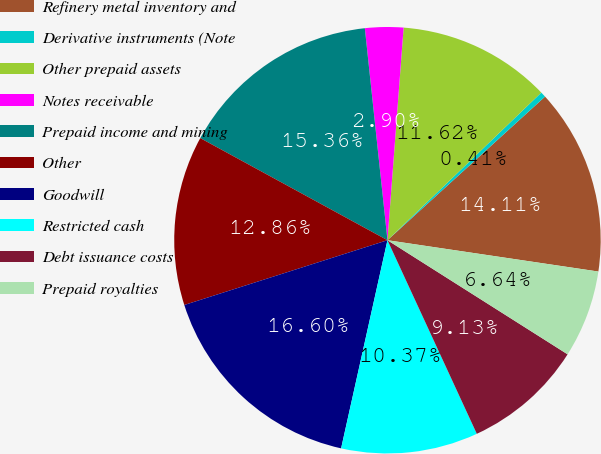Convert chart to OTSL. <chart><loc_0><loc_0><loc_500><loc_500><pie_chart><fcel>Refinery metal inventory and<fcel>Derivative instruments (Note<fcel>Other prepaid assets<fcel>Notes receivable<fcel>Prepaid income and mining<fcel>Other<fcel>Goodwill<fcel>Restricted cash<fcel>Debt issuance costs<fcel>Prepaid royalties<nl><fcel>14.11%<fcel>0.41%<fcel>11.62%<fcel>2.9%<fcel>15.36%<fcel>12.86%<fcel>16.6%<fcel>10.37%<fcel>9.13%<fcel>6.64%<nl></chart> 